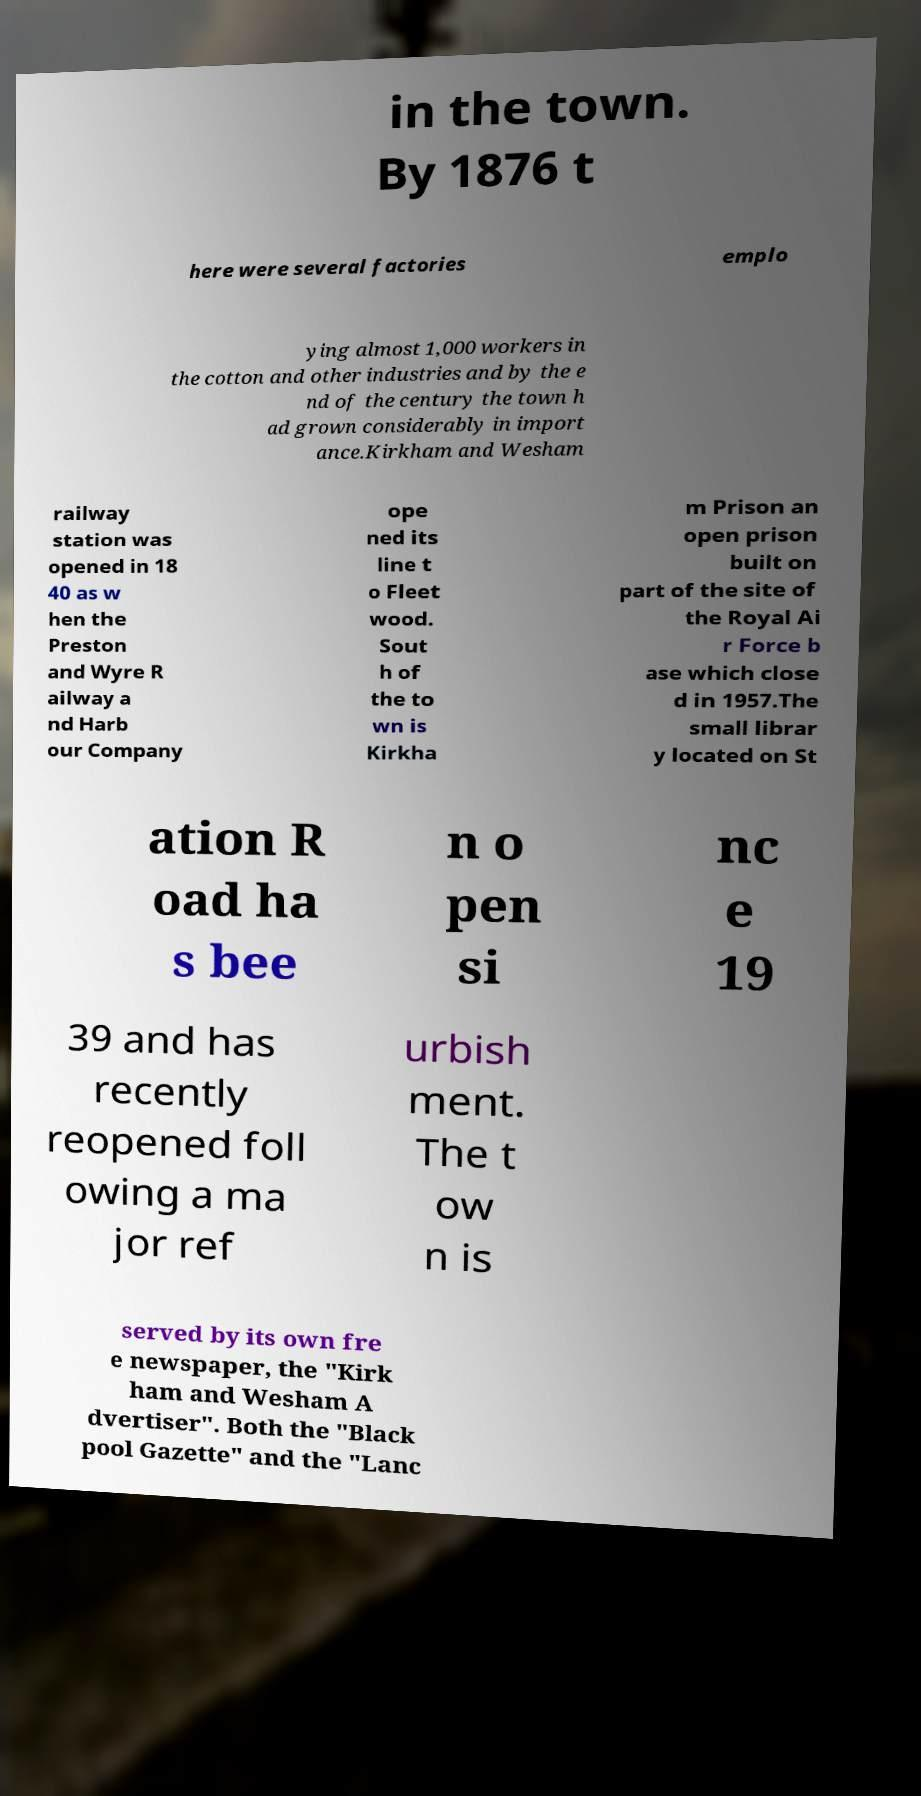Could you assist in decoding the text presented in this image and type it out clearly? in the town. By 1876 t here were several factories emplo ying almost 1,000 workers in the cotton and other industries and by the e nd of the century the town h ad grown considerably in import ance.Kirkham and Wesham railway station was opened in 18 40 as w hen the Preston and Wyre R ailway a nd Harb our Company ope ned its line t o Fleet wood. Sout h of the to wn is Kirkha m Prison an open prison built on part of the site of the Royal Ai r Force b ase which close d in 1957.The small librar y located on St ation R oad ha s bee n o pen si nc e 19 39 and has recently reopened foll owing a ma jor ref urbish ment. The t ow n is served by its own fre e newspaper, the "Kirk ham and Wesham A dvertiser". Both the "Black pool Gazette" and the "Lanc 